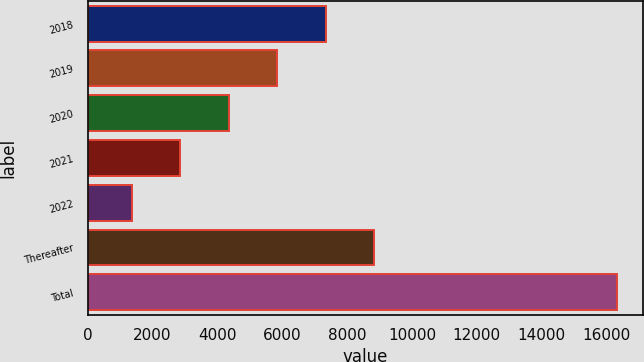<chart> <loc_0><loc_0><loc_500><loc_500><bar_chart><fcel>2018<fcel>2019<fcel>2020<fcel>2021<fcel>2022<fcel>Thereafter<fcel>Total<nl><fcel>7336.6<fcel>5841.2<fcel>4345.8<fcel>2850.4<fcel>1355<fcel>8832<fcel>16309<nl></chart> 